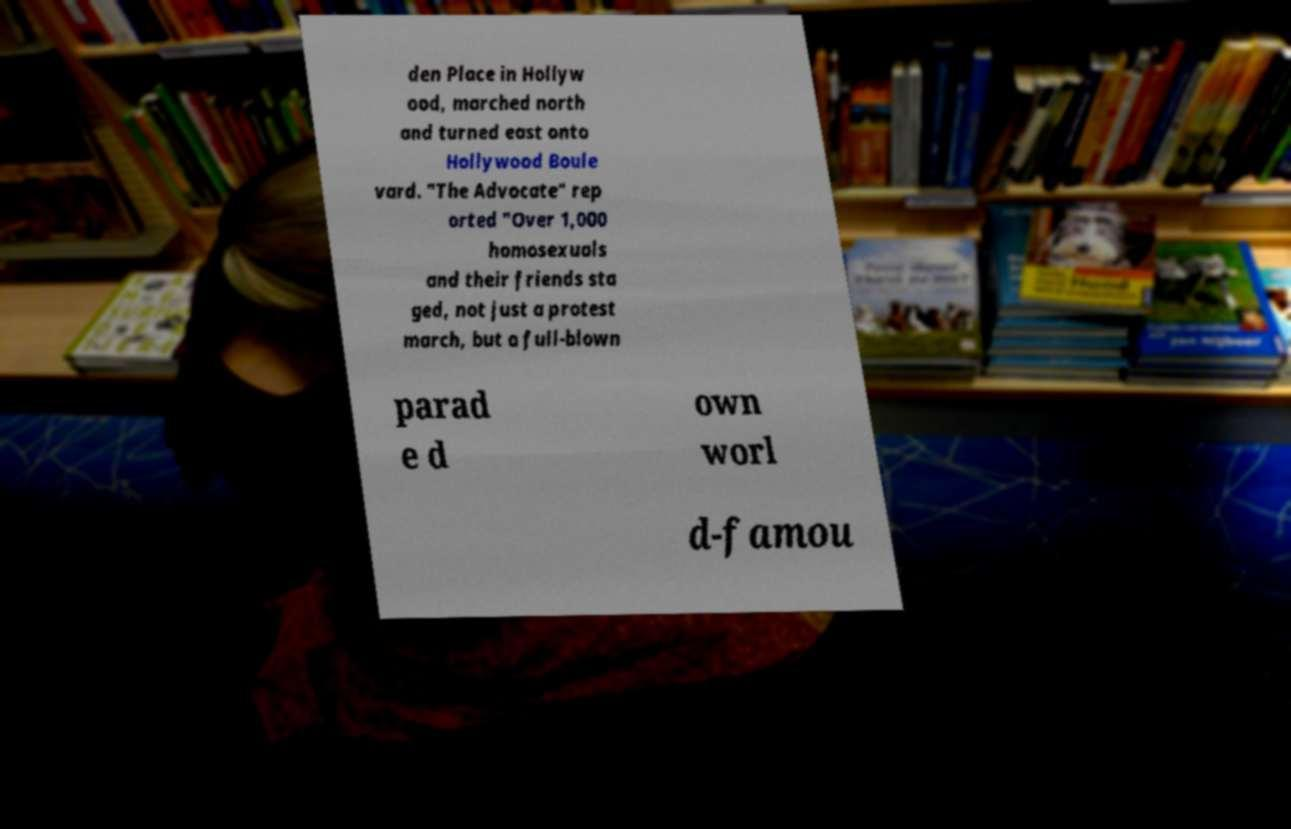Please identify and transcribe the text found in this image. den Place in Hollyw ood, marched north and turned east onto Hollywood Boule vard. "The Advocate" rep orted "Over 1,000 homosexuals and their friends sta ged, not just a protest march, but a full-blown parad e d own worl d-famou 